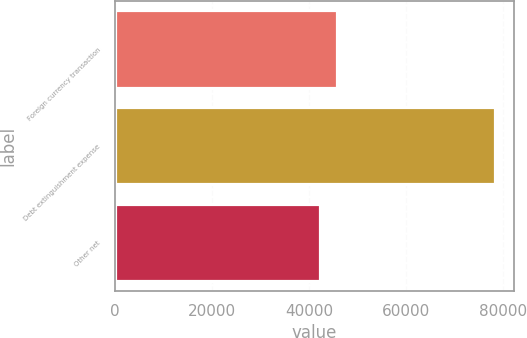Convert chart. <chart><loc_0><loc_0><loc_500><loc_500><bar_chart><fcel>Foreign currency transaction<fcel>Debt extinguishment expense<fcel>Other net<nl><fcel>45805.1<fcel>78368<fcel>42187<nl></chart> 